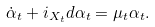Convert formula to latex. <formula><loc_0><loc_0><loc_500><loc_500>\dot { \alpha } _ { t } + i _ { X _ { t } } d \alpha _ { t } = \mu _ { t } \alpha _ { t } .</formula> 